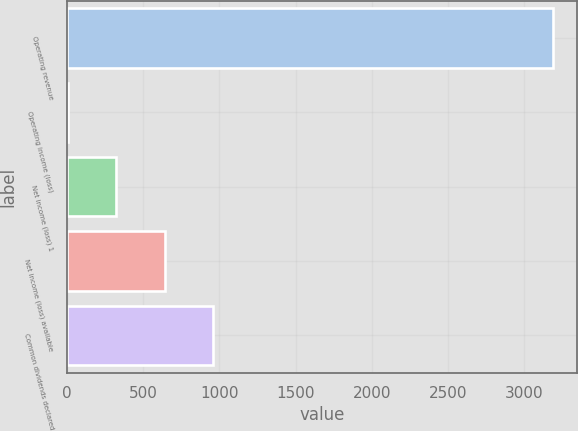Convert chart to OTSL. <chart><loc_0><loc_0><loc_500><loc_500><bar_chart><fcel>Operating revenue<fcel>Operating income (loss)<fcel>Net income (loss) 1<fcel>Net income (loss) available<fcel>Common dividends declared<nl><fcel>3193<fcel>4<fcel>322.9<fcel>641.8<fcel>960.7<nl></chart> 